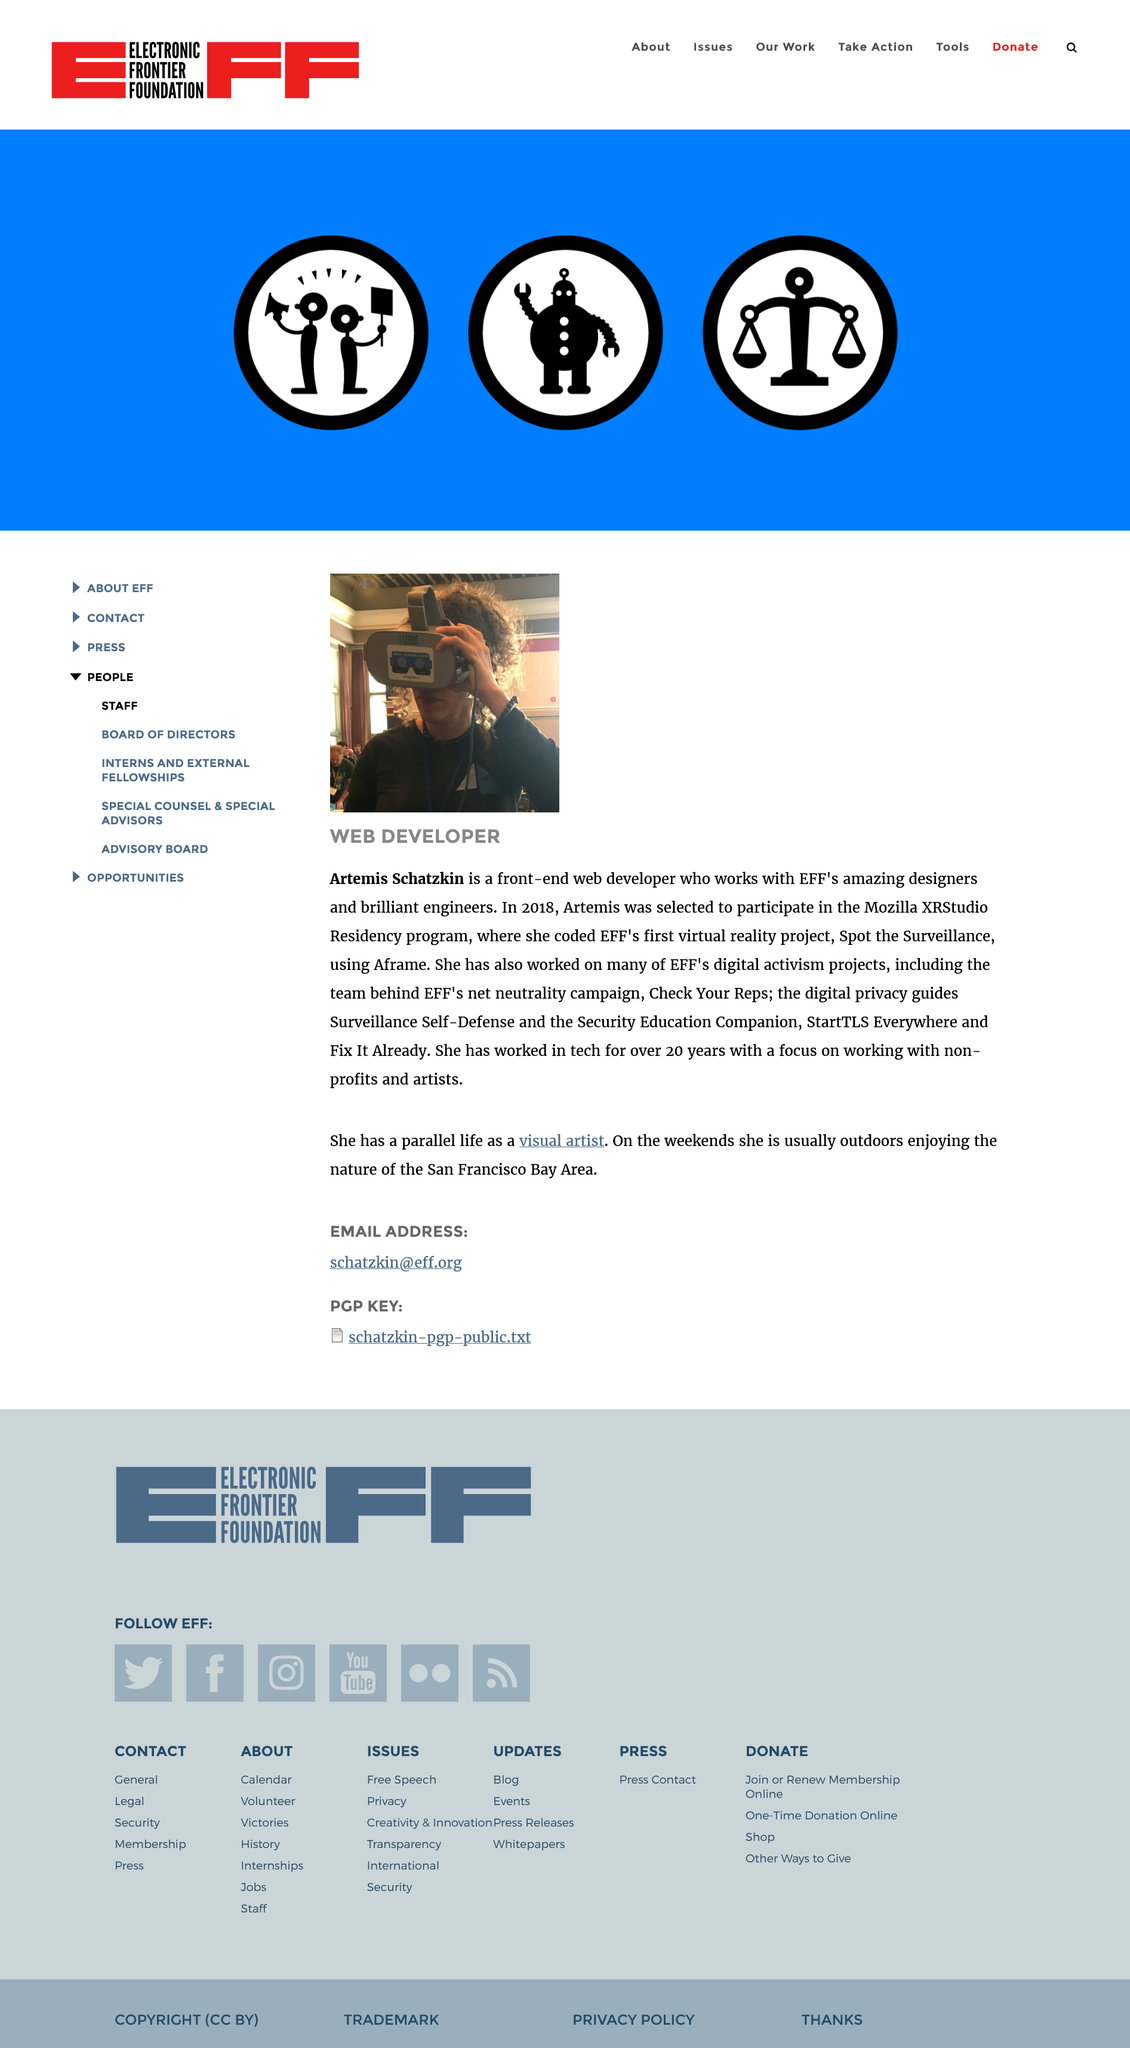Identify some key points in this picture. Artemis Schatzkin has been working in tech for over 20 years. Artemis Schatzkin is a front end developer who collaborates with the designers and engineers at EFF to contribute to the development and implementation of the organization's user interface designs. In 2018, Artemis Schatzkin developed and coded EFF's first virtual reality project, "Spot the Survelliance," using Aframe. 